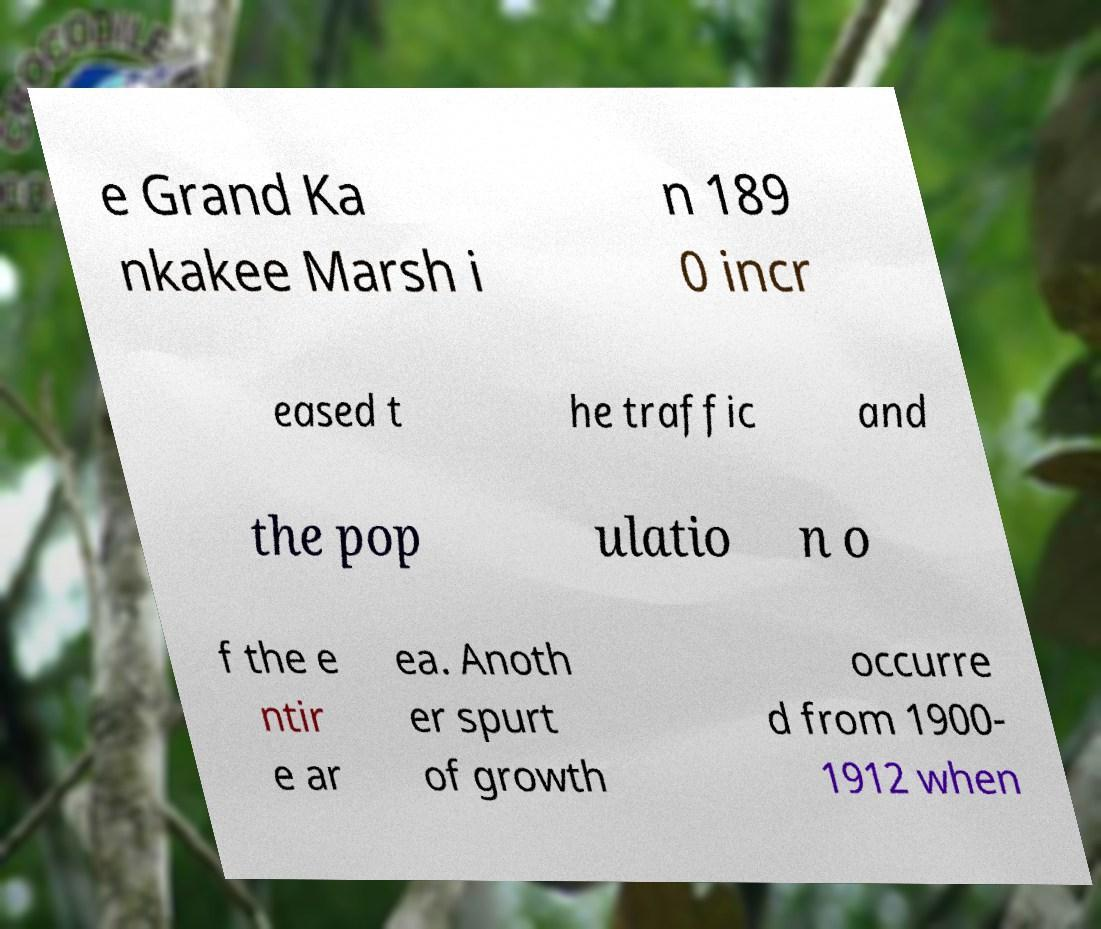Can you accurately transcribe the text from the provided image for me? e Grand Ka nkakee Marsh i n 189 0 incr eased t he traffic and the pop ulatio n o f the e ntir e ar ea. Anoth er spurt of growth occurre d from 1900- 1912 when 